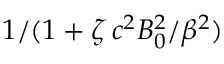<formula> <loc_0><loc_0><loc_500><loc_500>1 / ( 1 + \zeta \, c ^ { 2 } B _ { 0 } ^ { 2 } / \beta ^ { 2 } )</formula> 